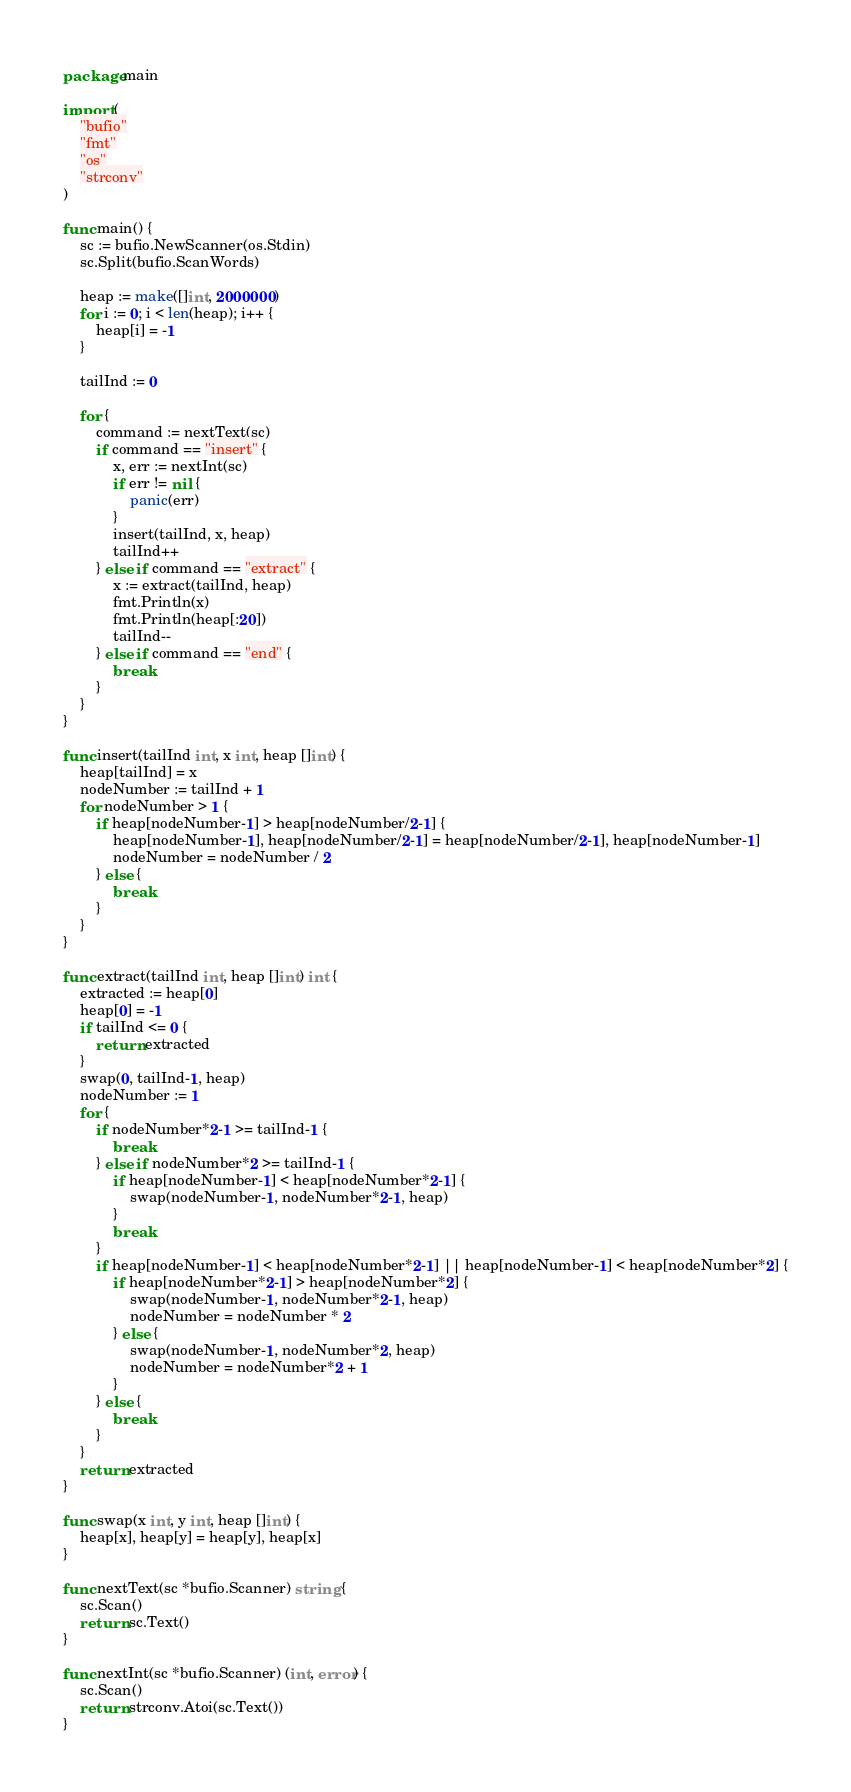Convert code to text. <code><loc_0><loc_0><loc_500><loc_500><_Go_>package main

import (
	"bufio"
	"fmt"
	"os"
	"strconv"
)

func main() {
	sc := bufio.NewScanner(os.Stdin)
	sc.Split(bufio.ScanWords)

	heap := make([]int, 2000000)
	for i := 0; i < len(heap); i++ {
		heap[i] = -1
	}

	tailInd := 0

	for {
		command := nextText(sc)
		if command == "insert" {
			x, err := nextInt(sc)
			if err != nil {
				panic(err)
			}
			insert(tailInd, x, heap)
			tailInd++
		} else if command == "extract" {
			x := extract(tailInd, heap)
			fmt.Println(x)
			fmt.Println(heap[:20])
			tailInd--
		} else if command == "end" {
			break
		}
	}
}

func insert(tailInd int, x int, heap []int) {
	heap[tailInd] = x
	nodeNumber := tailInd + 1
	for nodeNumber > 1 {
		if heap[nodeNumber-1] > heap[nodeNumber/2-1] {
			heap[nodeNumber-1], heap[nodeNumber/2-1] = heap[nodeNumber/2-1], heap[nodeNumber-1]
			nodeNumber = nodeNumber / 2
		} else {
			break
		}
	}
}

func extract(tailInd int, heap []int) int {
	extracted := heap[0]
	heap[0] = -1
	if tailInd <= 0 {
		return extracted
	}
	swap(0, tailInd-1, heap)
	nodeNumber := 1
	for {
		if nodeNumber*2-1 >= tailInd-1 {
			break
		} else if nodeNumber*2 >= tailInd-1 {
			if heap[nodeNumber-1] < heap[nodeNumber*2-1] {
				swap(nodeNumber-1, nodeNumber*2-1, heap)
			}
			break
		}
		if heap[nodeNumber-1] < heap[nodeNumber*2-1] || heap[nodeNumber-1] < heap[nodeNumber*2] {
			if heap[nodeNumber*2-1] > heap[nodeNumber*2] {
				swap(nodeNumber-1, nodeNumber*2-1, heap)
				nodeNumber = nodeNumber * 2
			} else {
				swap(nodeNumber-1, nodeNumber*2, heap)
				nodeNumber = nodeNumber*2 + 1
			}
		} else {
			break
		}
	}
	return extracted
}

func swap(x int, y int, heap []int) {
	heap[x], heap[y] = heap[y], heap[x]
}

func nextText(sc *bufio.Scanner) string {
	sc.Scan()
	return sc.Text()
}

func nextInt(sc *bufio.Scanner) (int, error) {
	sc.Scan()
	return strconv.Atoi(sc.Text())
}

</code> 